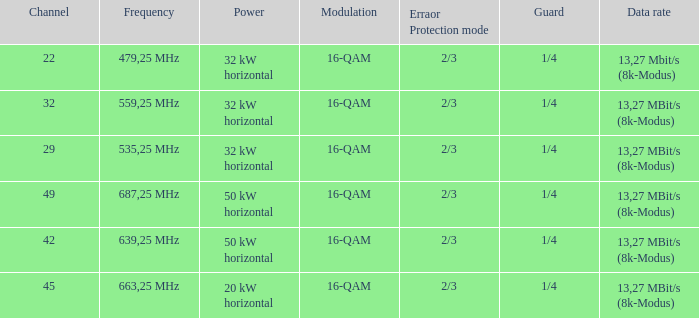For channel 32 with a horizontal power of 32 kw, what is the corresponding modulation? 16-QAM. 